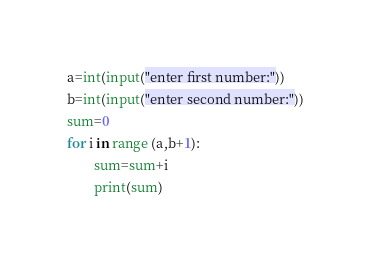Convert code to text. <code><loc_0><loc_0><loc_500><loc_500><_Python_>a=int(input("enter first number:"))
b=int(input("enter second number:"))
sum=0
for i in range (a,b+1):
        sum=sum+i
        print(sum)
</code> 